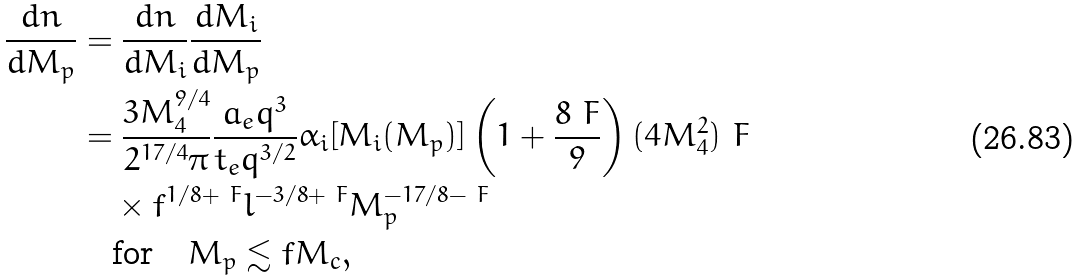Convert formula to latex. <formula><loc_0><loc_0><loc_500><loc_500>\frac { d n } { d M _ { p } } & = \frac { d n } { d M _ { i } } \frac { d M _ { i } } { d M _ { p } } \\ & = \frac { 3 M _ { 4 } ^ { 9 / 4 } } { 2 ^ { 1 7 / 4 } \pi } \frac { a _ { e } q ^ { 3 } } { t _ { e } q ^ { 3 / 2 } } \alpha _ { i } [ M _ { i } ( M _ { p } ) ] \left ( 1 + \frac { 8 \ F } { 9 } \right ) ( 4 M _ { 4 } ^ { 2 } ) ^ { \ } F \\ & \quad \times f ^ { 1 / 8 + \ F } l ^ { - 3 / 8 + \ F } M _ { p } ^ { - 1 7 / 8 - \ F } \\ & \quad \text {for} \quad M _ { p } \lesssim f M _ { c } ,</formula> 